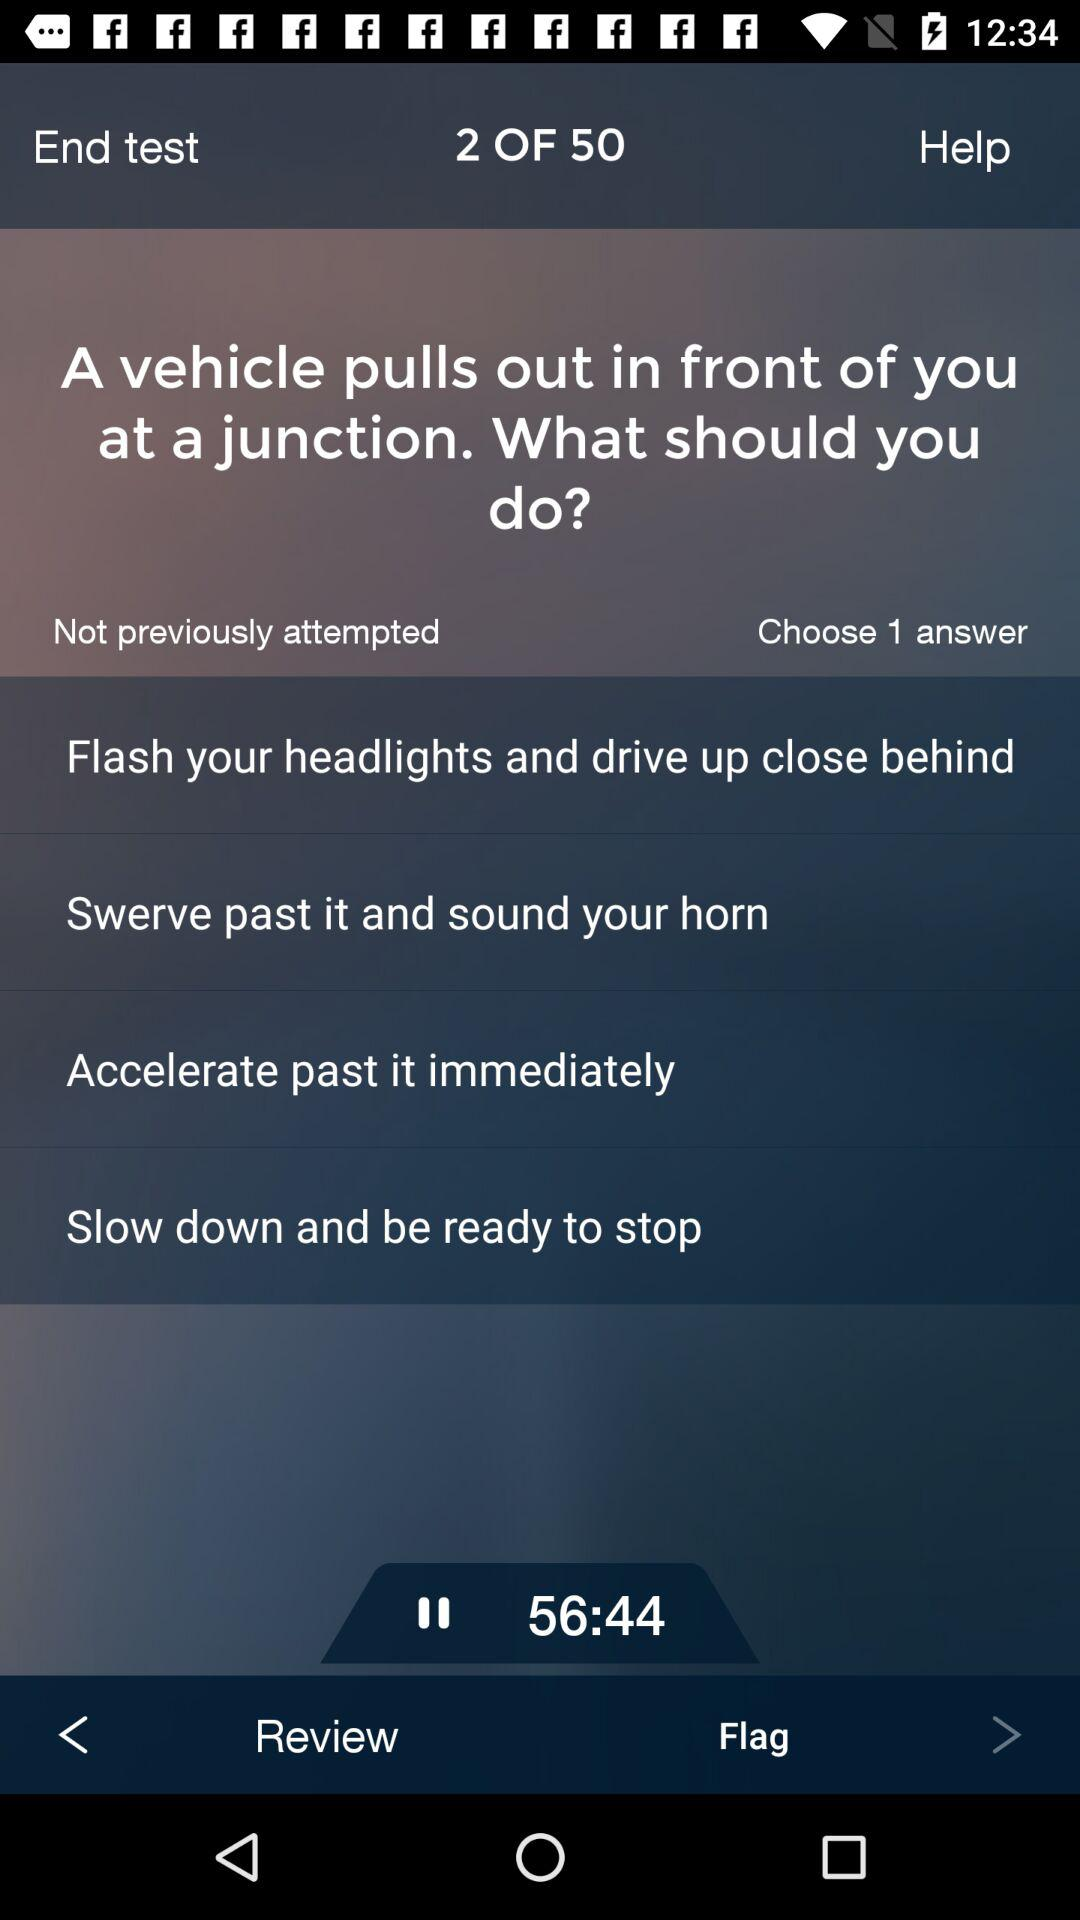How many answers we have to choose? You have to choose 1 answer. 